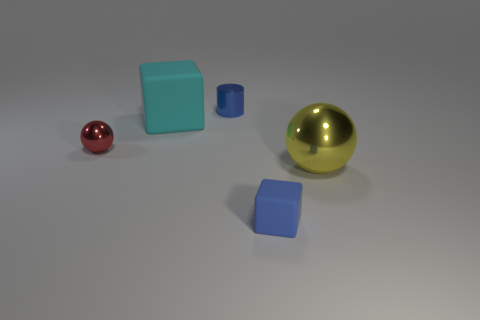Is there anything else that is the same shape as the blue shiny object?
Give a very brief answer. No. There is another cube that is made of the same material as the small cube; what color is it?
Give a very brief answer. Cyan. What number of blue blocks have the same size as the cyan cube?
Give a very brief answer. 0. How many yellow things are small shiny cylinders or tiny shiny objects?
Your answer should be very brief. 0. How many objects are yellow metal balls or rubber blocks behind the blue matte cube?
Keep it short and to the point. 2. What is the large object that is right of the large rubber thing made of?
Offer a terse response. Metal. There is a matte object that is the same size as the red metallic sphere; what shape is it?
Give a very brief answer. Cube. Is there another small green rubber object that has the same shape as the tiny rubber object?
Your answer should be compact. No. Does the big cyan thing have the same material as the blue object that is behind the blue rubber object?
Your response must be concise. No. The block that is behind the tiny thing that is in front of the red metal thing is made of what material?
Provide a short and direct response. Rubber. 